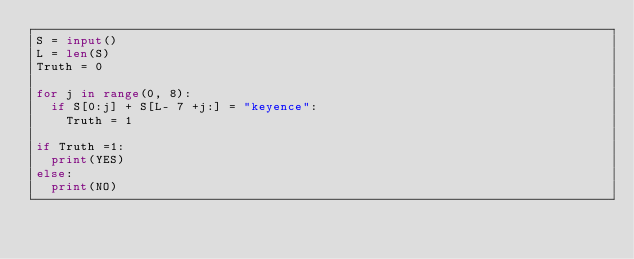<code> <loc_0><loc_0><loc_500><loc_500><_Python_>S = input()
L = len(S)
Truth = 0

for j in range(0, 8):
	if S[0:j] + S[L- 7 +j:] = "keyence":
		Truth = 1

if Truth =1:
	print(YES)
else:
	print(NO)</code> 